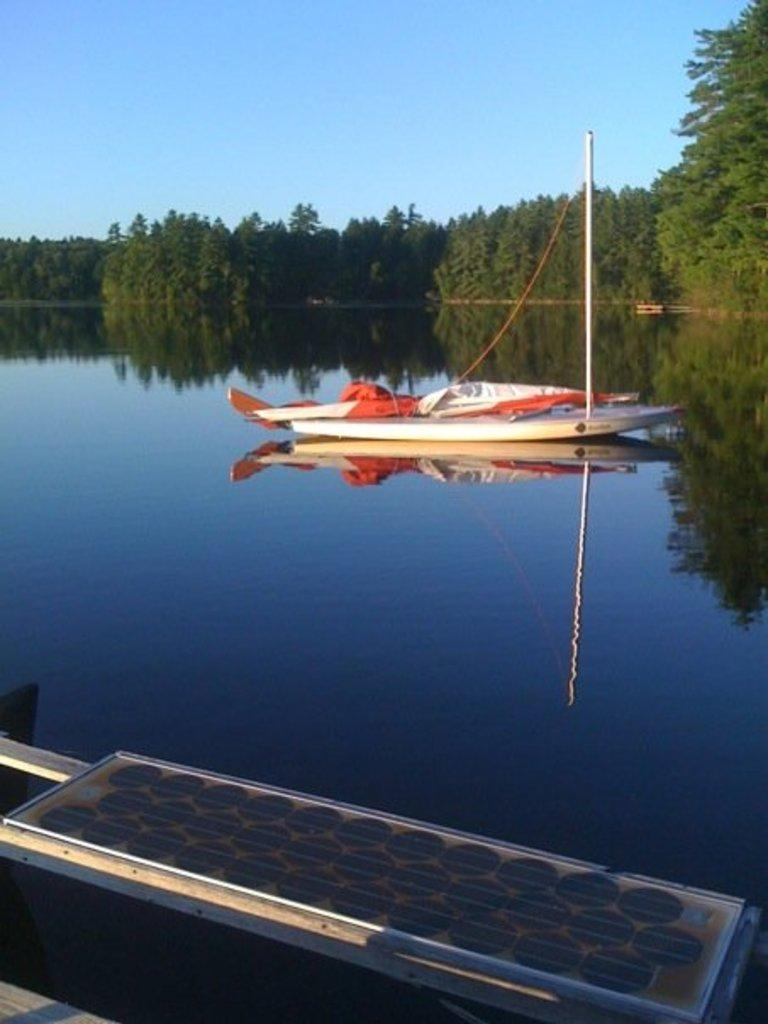What is the main subject of the image? The main subject of the image is a boat. Where is the boat located? The boat is on the water. What are some features of the boat? The boat has a pole, a rope, and a cover. What is at the bottom of the image? There is an object at the bottom of the image. What can be seen in the background of the image? There are trees and the sky visible in the background of the image. What is the income of the snails in the image? There are no snails present in the image, so it is not possible to determine their income. How many sticks are visible in the image? There are no sticks visible in the image. 